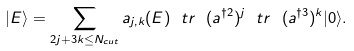<formula> <loc_0><loc_0><loc_500><loc_500>| E \rangle = \sum _ { 2 j + 3 k \leq N _ { c u t } } a _ { j , k } ( E ) \ t r \ ( a ^ { \dagger 2 } ) ^ { j } \ t r \ ( a ^ { \dagger 3 } ) ^ { k } | 0 \rangle .</formula> 